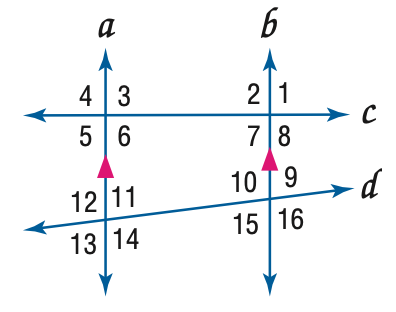Answer the mathemtical geometry problem and directly provide the correct option letter.
Question: In the figure, m \angle 4 = 104, m \angle 14 = 118. Find the measure of \angle 10.
Choices: A: 62 B: 76 C: 104 D: 118 D 